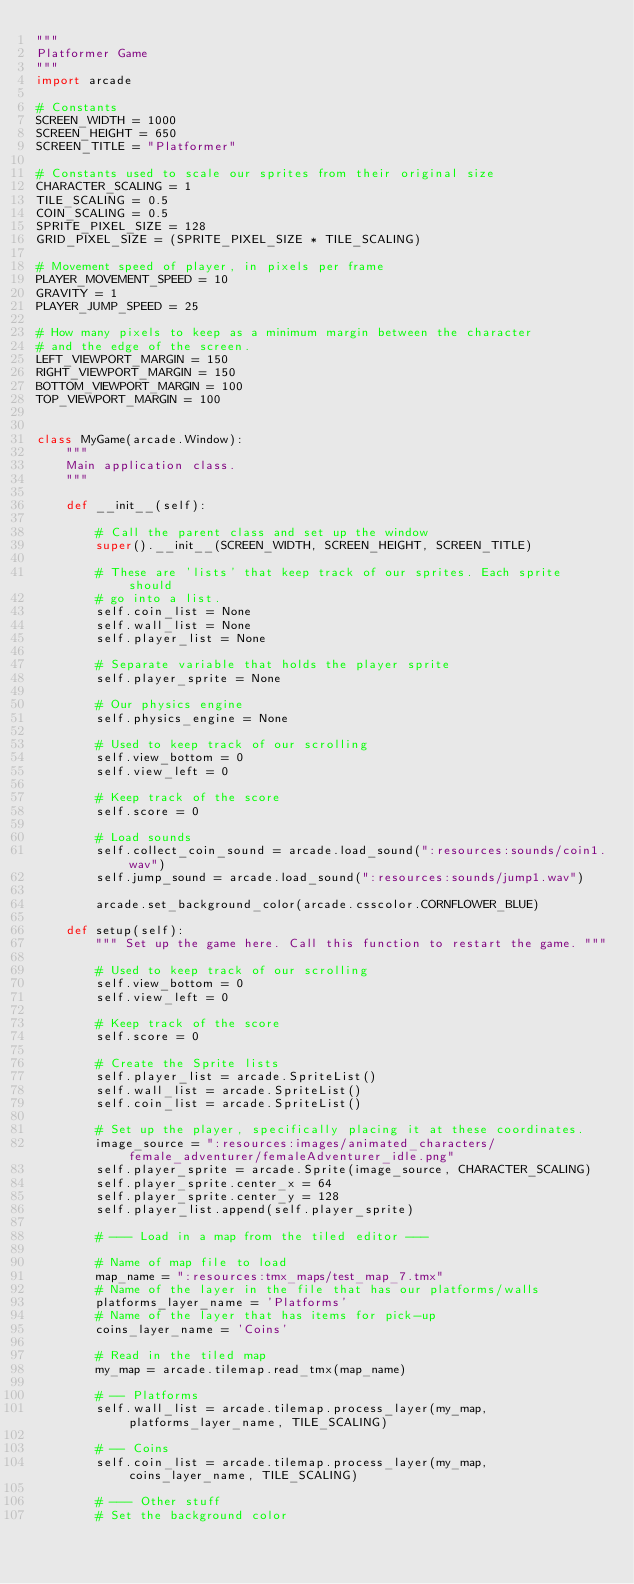<code> <loc_0><loc_0><loc_500><loc_500><_Python_>"""
Platformer Game
"""
import arcade

# Constants
SCREEN_WIDTH = 1000
SCREEN_HEIGHT = 650
SCREEN_TITLE = "Platformer"

# Constants used to scale our sprites from their original size
CHARACTER_SCALING = 1
TILE_SCALING = 0.5
COIN_SCALING = 0.5
SPRITE_PIXEL_SIZE = 128
GRID_PIXEL_SIZE = (SPRITE_PIXEL_SIZE * TILE_SCALING)

# Movement speed of player, in pixels per frame
PLAYER_MOVEMENT_SPEED = 10
GRAVITY = 1
PLAYER_JUMP_SPEED = 25

# How many pixels to keep as a minimum margin between the character
# and the edge of the screen.
LEFT_VIEWPORT_MARGIN = 150
RIGHT_VIEWPORT_MARGIN = 150
BOTTOM_VIEWPORT_MARGIN = 100
TOP_VIEWPORT_MARGIN = 100


class MyGame(arcade.Window):
    """
    Main application class.
    """

    def __init__(self):

        # Call the parent class and set up the window
        super().__init__(SCREEN_WIDTH, SCREEN_HEIGHT, SCREEN_TITLE)

        # These are 'lists' that keep track of our sprites. Each sprite should
        # go into a list.
        self.coin_list = None
        self.wall_list = None
        self.player_list = None

        # Separate variable that holds the player sprite
        self.player_sprite = None

        # Our physics engine
        self.physics_engine = None

        # Used to keep track of our scrolling
        self.view_bottom = 0
        self.view_left = 0

        # Keep track of the score
        self.score = 0

        # Load sounds
        self.collect_coin_sound = arcade.load_sound(":resources:sounds/coin1.wav")
        self.jump_sound = arcade.load_sound(":resources:sounds/jump1.wav")

        arcade.set_background_color(arcade.csscolor.CORNFLOWER_BLUE)

    def setup(self):
        """ Set up the game here. Call this function to restart the game. """

        # Used to keep track of our scrolling
        self.view_bottom = 0
        self.view_left = 0

        # Keep track of the score
        self.score = 0

        # Create the Sprite lists
        self.player_list = arcade.SpriteList()
        self.wall_list = arcade.SpriteList()
        self.coin_list = arcade.SpriteList()

        # Set up the player, specifically placing it at these coordinates.
        image_source = ":resources:images/animated_characters/female_adventurer/femaleAdventurer_idle.png"
        self.player_sprite = arcade.Sprite(image_source, CHARACTER_SCALING)
        self.player_sprite.center_x = 64
        self.player_sprite.center_y = 128
        self.player_list.append(self.player_sprite)

        # --- Load in a map from the tiled editor ---

        # Name of map file to load
        map_name = ":resources:tmx_maps/test_map_7.tmx"
        # Name of the layer in the file that has our platforms/walls
        platforms_layer_name = 'Platforms'
        # Name of the layer that has items for pick-up
        coins_layer_name = 'Coins'

        # Read in the tiled map
        my_map = arcade.tilemap.read_tmx(map_name)

        # -- Platforms
        self.wall_list = arcade.tilemap.process_layer(my_map, platforms_layer_name, TILE_SCALING)

        # -- Coins
        self.coin_list = arcade.tilemap.process_layer(my_map, coins_layer_name, TILE_SCALING)

        # --- Other stuff
        # Set the background color</code> 